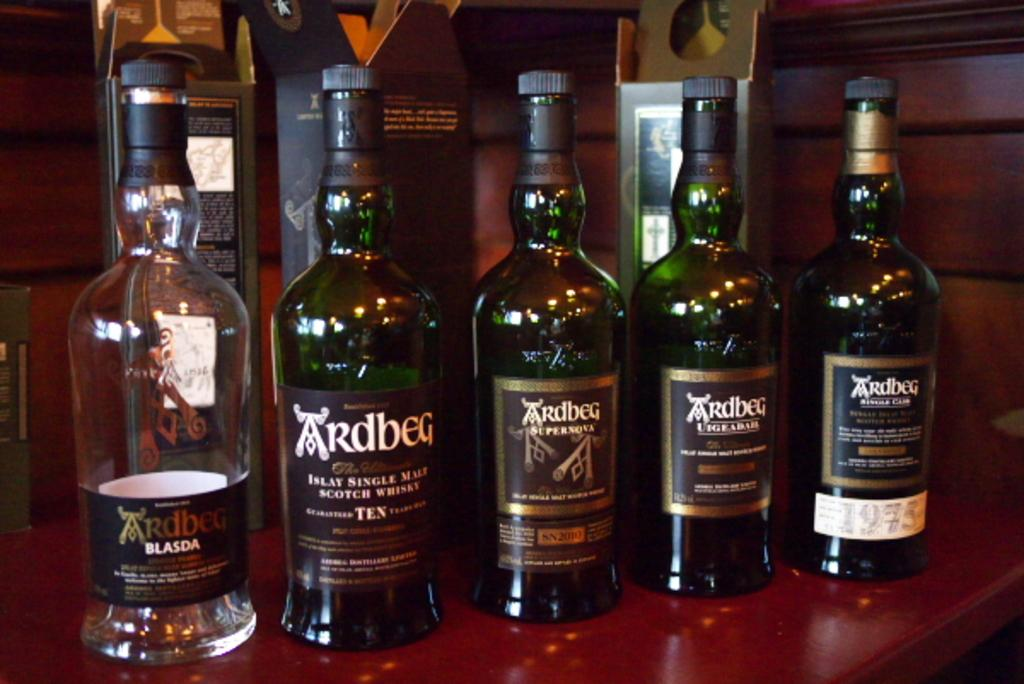<image>
Create a compact narrative representing the image presented. the word Ardbeg that is on some beer bottles 